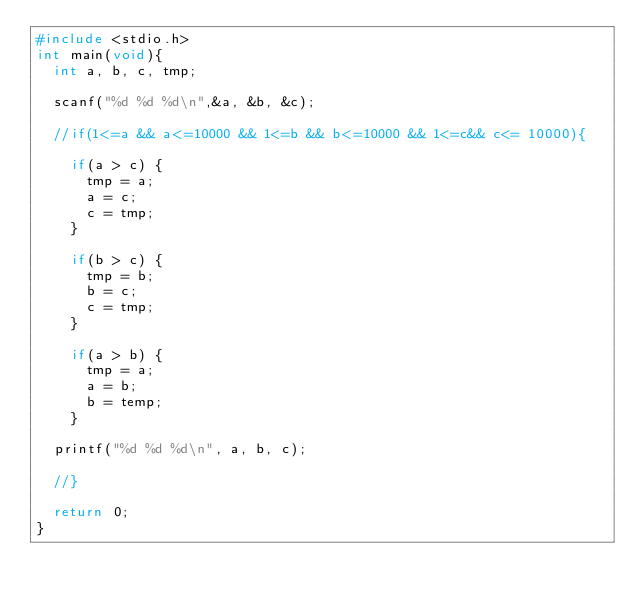Convert code to text. <code><loc_0><loc_0><loc_500><loc_500><_C_>#include <stdio.h>
int main(void){
  int a, b, c, tmp;

  scanf("%d %d %d\n",&a, &b, &c);

  //if(1<=a && a<=10000 && 1<=b && b<=10000 && 1<=c&& c<= 10000){
    
    if(a > c) {
      tmp = a;
      a = c;
      c = tmp;
    }

    if(b > c) {
      tmp = b;
      b = c;
      c = tmp;
    }

    if(a > b) {
      tmp = a;
      a = b;
      b = temp;
    }

  printf("%d %d %d\n", a, b, c);

  //}

  return 0;
}</code> 